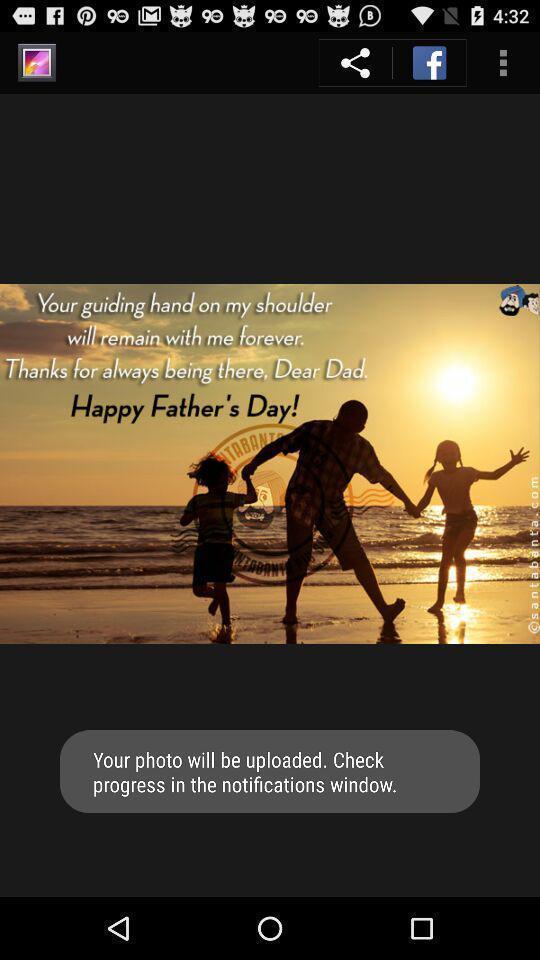Provide a textual representation of this image. Screen displaying a quote on father 's day. 